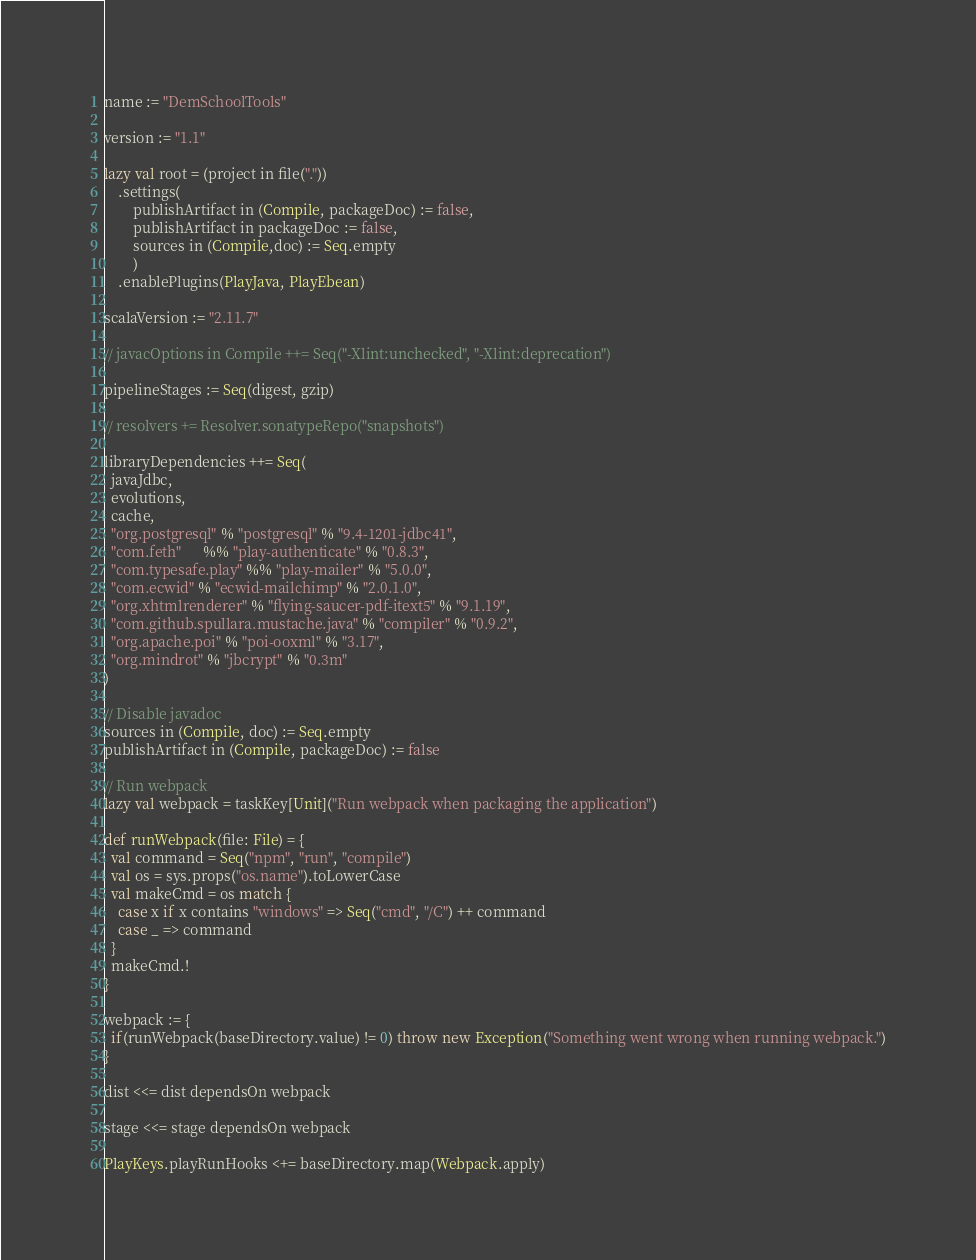<code> <loc_0><loc_0><loc_500><loc_500><_Scala_>name := "DemSchoolTools"

version := "1.1"

lazy val root = (project in file("."))
	.settings(
		publishArtifact in (Compile, packageDoc) := false,
		publishArtifact in packageDoc := false,
		sources in (Compile,doc) := Seq.empty
	    )
	.enablePlugins(PlayJava, PlayEbean)

scalaVersion := "2.11.7"

// javacOptions in Compile ++= Seq("-Xlint:unchecked", "-Xlint:deprecation")

pipelineStages := Seq(digest, gzip)

// resolvers += Resolver.sonatypeRepo("snapshots")

libraryDependencies ++= Seq(
  javaJdbc,
  evolutions,
  cache,
  "org.postgresql" % "postgresql" % "9.4-1201-jdbc41",
  "com.feth"      %% "play-authenticate" % "0.8.3",
  "com.typesafe.play" %% "play-mailer" % "5.0.0",
  "com.ecwid" % "ecwid-mailchimp" % "2.0.1.0",
  "org.xhtmlrenderer" % "flying-saucer-pdf-itext5" % "9.1.19",
  "com.github.spullara.mustache.java" % "compiler" % "0.9.2",
  "org.apache.poi" % "poi-ooxml" % "3.17",
  "org.mindrot" % "jbcrypt" % "0.3m"
)

// Disable javadoc
sources in (Compile, doc) := Seq.empty
publishArtifact in (Compile, packageDoc) := false

// Run webpack
lazy val webpack = taskKey[Unit]("Run webpack when packaging the application")

def runWebpack(file: File) = {
  val command = Seq("npm", "run", "compile")
  val os = sys.props("os.name").toLowerCase
  val makeCmd = os match {
    case x if x contains "windows" => Seq("cmd", "/C") ++ command
    case _ => command
  }
  makeCmd.!
}

webpack := {
  if(runWebpack(baseDirectory.value) != 0) throw new Exception("Something went wrong when running webpack.")
}

dist <<= dist dependsOn webpack

stage <<= stage dependsOn webpack

PlayKeys.playRunHooks <+= baseDirectory.map(Webpack.apply)
</code> 